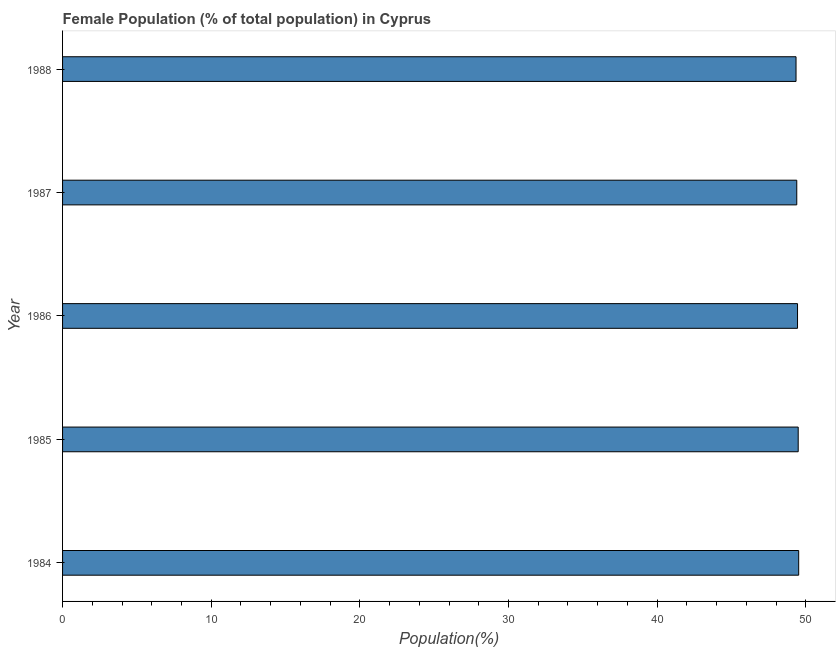Does the graph contain any zero values?
Offer a terse response. No. What is the title of the graph?
Ensure brevity in your answer.  Female Population (% of total population) in Cyprus. What is the label or title of the X-axis?
Ensure brevity in your answer.  Population(%). What is the label or title of the Y-axis?
Keep it short and to the point. Year. What is the female population in 1985?
Provide a succinct answer. 49.49. Across all years, what is the maximum female population?
Keep it short and to the point. 49.52. Across all years, what is the minimum female population?
Offer a very short reply. 49.34. In which year was the female population maximum?
Provide a short and direct response. 1984. In which year was the female population minimum?
Offer a terse response. 1988. What is the sum of the female population?
Provide a succinct answer. 247.18. What is the difference between the female population in 1987 and 1988?
Offer a very short reply. 0.05. What is the average female population per year?
Your answer should be very brief. 49.44. What is the median female population?
Give a very brief answer. 49.44. What is the difference between the highest and the second highest female population?
Make the answer very short. 0.03. What is the difference between the highest and the lowest female population?
Your answer should be very brief. 0.18. In how many years, is the female population greater than the average female population taken over all years?
Provide a succinct answer. 3. How many bars are there?
Ensure brevity in your answer.  5. How many years are there in the graph?
Give a very brief answer. 5. What is the difference between two consecutive major ticks on the X-axis?
Make the answer very short. 10. What is the Population(%) of 1984?
Offer a terse response. 49.52. What is the Population(%) of 1985?
Offer a terse response. 49.49. What is the Population(%) in 1986?
Offer a very short reply. 49.44. What is the Population(%) of 1987?
Offer a very short reply. 49.39. What is the Population(%) in 1988?
Offer a very short reply. 49.34. What is the difference between the Population(%) in 1984 and 1985?
Offer a very short reply. 0.03. What is the difference between the Population(%) in 1984 and 1986?
Provide a succinct answer. 0.08. What is the difference between the Population(%) in 1984 and 1987?
Provide a succinct answer. 0.13. What is the difference between the Population(%) in 1984 and 1988?
Your answer should be very brief. 0.18. What is the difference between the Population(%) in 1985 and 1986?
Your answer should be very brief. 0.04. What is the difference between the Population(%) in 1985 and 1987?
Provide a short and direct response. 0.1. What is the difference between the Population(%) in 1985 and 1988?
Offer a very short reply. 0.15. What is the difference between the Population(%) in 1986 and 1987?
Provide a short and direct response. 0.05. What is the difference between the Population(%) in 1986 and 1988?
Your response must be concise. 0.1. What is the difference between the Population(%) in 1987 and 1988?
Your answer should be very brief. 0.05. What is the ratio of the Population(%) in 1984 to that in 1986?
Make the answer very short. 1. What is the ratio of the Population(%) in 1984 to that in 1987?
Your response must be concise. 1. What is the ratio of the Population(%) in 1985 to that in 1987?
Ensure brevity in your answer.  1. What is the ratio of the Population(%) in 1985 to that in 1988?
Ensure brevity in your answer.  1. What is the ratio of the Population(%) in 1986 to that in 1988?
Provide a succinct answer. 1. What is the ratio of the Population(%) in 1987 to that in 1988?
Offer a very short reply. 1. 